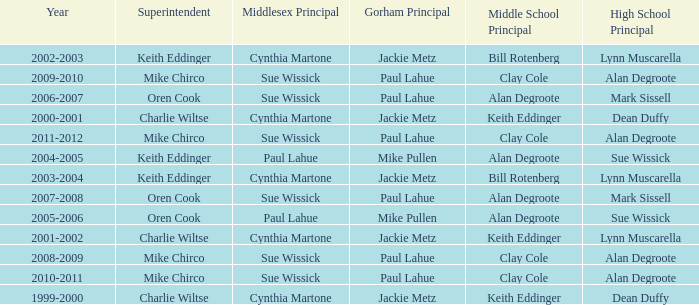How many years was lynn muscarella the high school principal and charlie wiltse the superintendent? 1.0. 